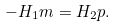<formula> <loc_0><loc_0><loc_500><loc_500>- H _ { 1 } m = H _ { 2 } p .</formula> 